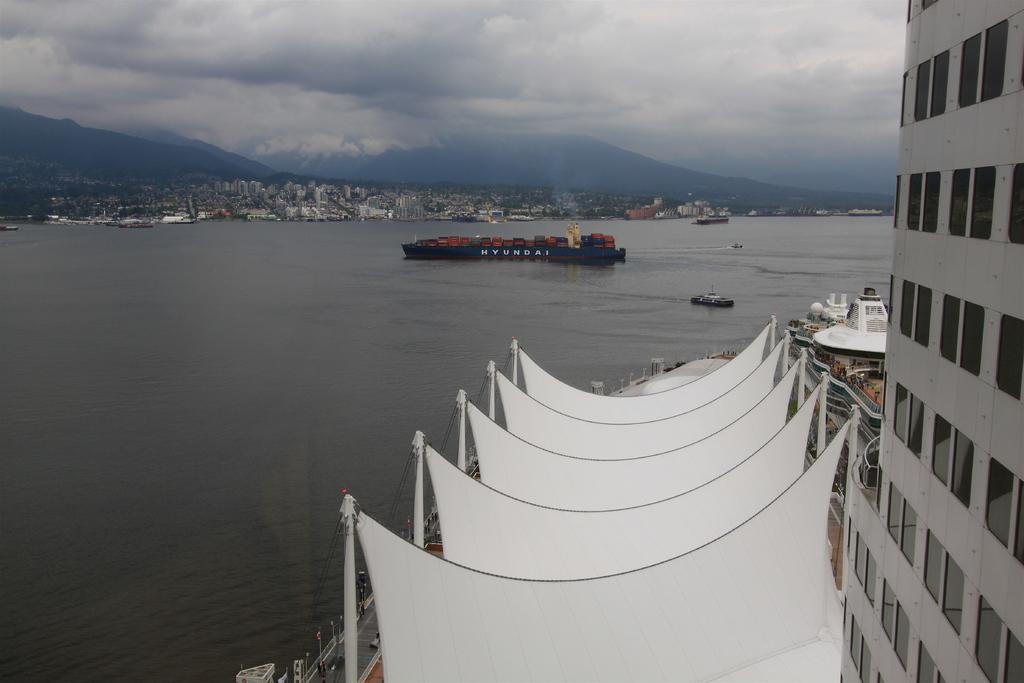What is the main subject of the image? The main subject of the image is ships on a river. What can be seen in the background of the image? In the background of the image, there are buildings, mountains, and the sky. Can you describe the building on the right side of the image? Yes, there is a building on the right side of the image. How many elements are present in the background of the image? There are four elements present in the background: buildings, mountains, the sky, and the river. How many eggs are visible in the image? There are no eggs present in the image. What type of boundary can be seen separating the river and the mountains in the image? There is no boundary separating the river and the mountains in the image; they are naturally connected. 